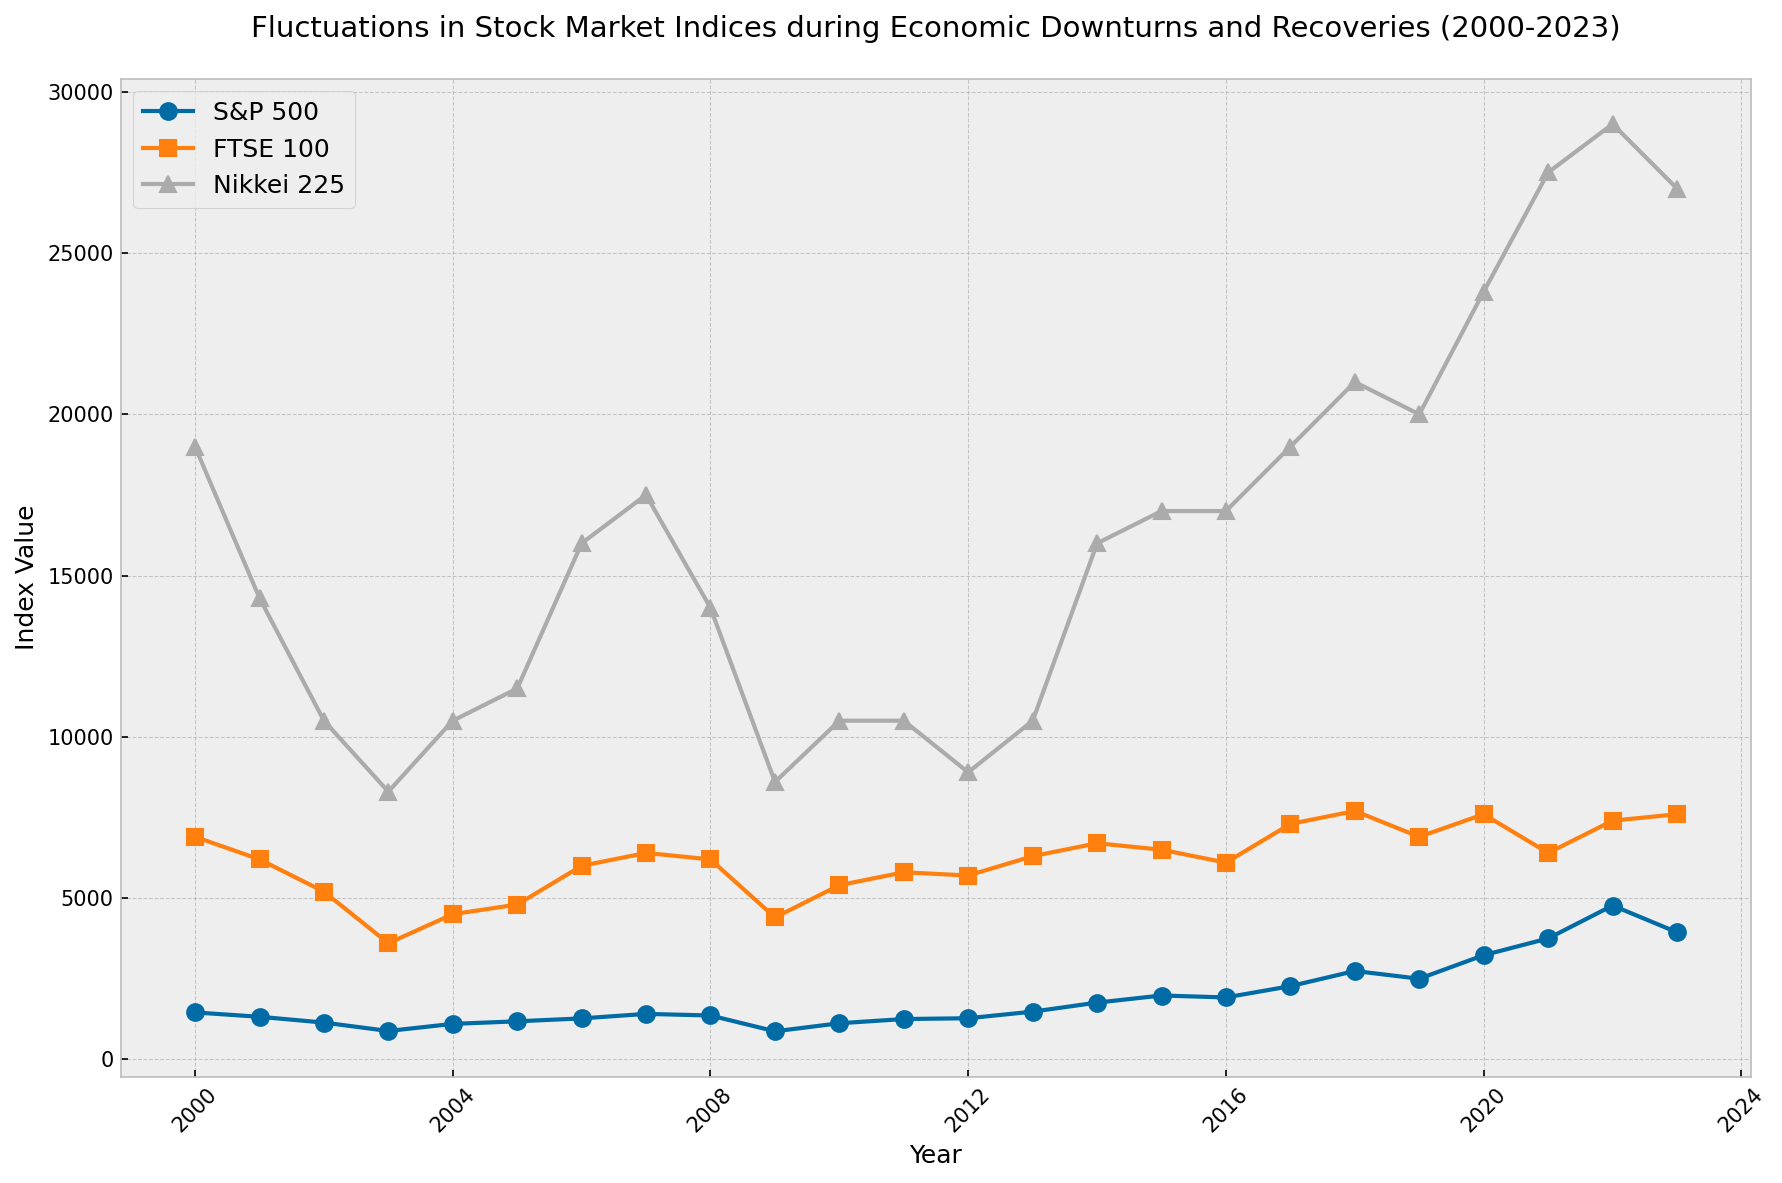What are the highest and lowest values of the S&P 500 index shown in the plot? Look at the plot and identify the highest and lowest points for the S&P 500 line. The highest value is at 2022 (4770) and the lowest value is at 2009 (870).
Answer: Highest: 4770, Lowest: 870 Which year showed a significant drop for both the S&P 500 and Nikkei 225 indices? Examine the trend lines for both indices and find the year where both show a noticeable drop. Both the S&P 500 and Nikkei 225 dropped significantly in 2009.
Answer: 2009 How does the Nikkei 225 index compare with the FTSE 100 in 2020? Observe the values of the Nikkei 225 and FTSE 100 indices for the year 2020. The Nikkei 225 is significantly higher at 23800 compared to the FTSE 100 at 7600.
Answer: Nikkei 225 is higher What is the average value of the FTSE 100 index from 2000 to 2009? Extract the FTSE 100 values for the years 2000 to 2009 and calculate the average. The values are 6900, 6200, 5200, 3600, 4500, 4800, 6000, 6400, 6200, 4400. The sum is 53200, so the average is 53200/10 = 5320.
Answer: 5320 Which index showed the most consistent growth from 2010 to 2018? Examine the growth patterns of all three indices between 2010 and 2018 and identify the one that shows a relatively steady increase. The S&P 500 shows the most consistent growth over this period.
Answer: S&P 500 Was there any year where all three indices showed a drop from the previous year? Check each year’s values for all indices and see if there’s any year where all three lines drop compared to the prior year’s values. In 2009, all three indices (S&P 500, FTSE 100, Nikkei 225) dropped from 2008.
Answer: 2009 Which index showed the highest increase in value between 2012 and 2014? Calculate the difference in values between 2012 and 2014 for each index. For S&P 500: 1760 - 1275 = 485, FTSE 100: 6700 - 5700 = 1000, Nikkei 225: 16000 - 8900 = 7100. The Nikkei 225 showed the highest increase.
Answer: Nikkei 225 Compare the recovery pattern of the S&P 500 and FTSE 100 indices after 2009. Examine the trend lines for S&P 500 and FTSE 100 from 2009 onwards and describe their recovery patterns. The S&P 500 shows a more rapid and continuous increase compared to the FTSE 100, which has a more gradual recovery.
Answer: S&P 500: rapid recovery, FTSE 100: gradual recovery 